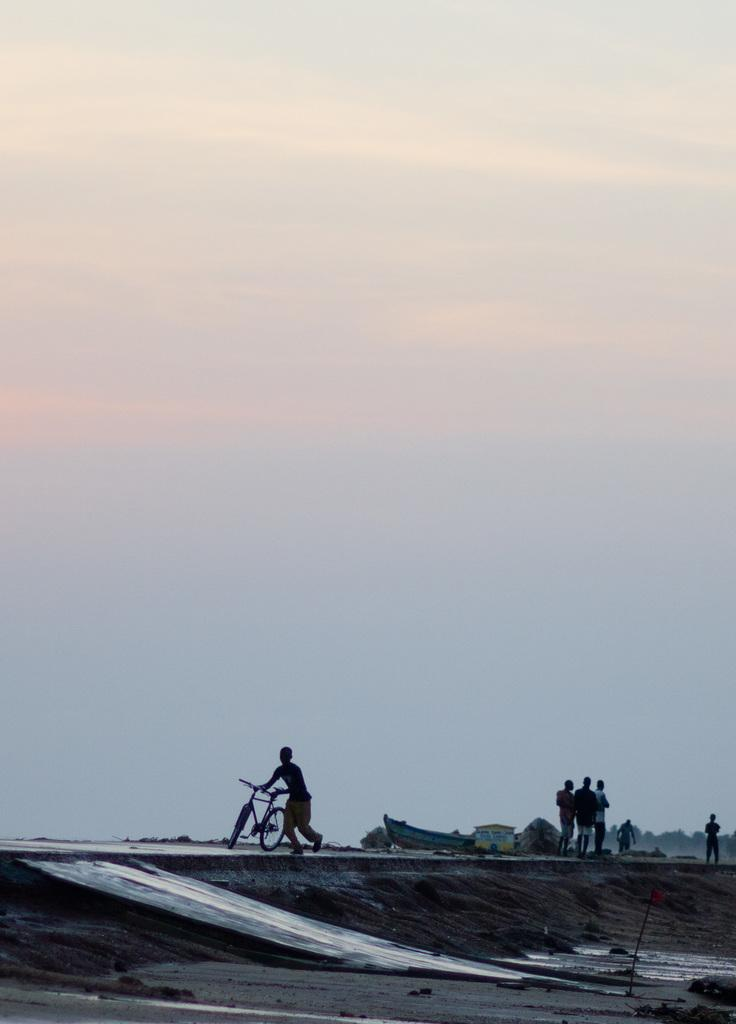How many people are in the image? There are people in the image, but the exact number is not specified. What is one person doing in the image? One person is walking and holding a bicycle. What is another object or structure in the image? There is a boat in the image. What type of building can be seen in the image? There is a house in the image. What can be seen in the background of the image? There are trees and the sky visible in the background of the image. How many vacation-ready is the person's finger in the image? There is no mention of a finger or vacation-readiness in the image, so it is not possible to answer that question. 